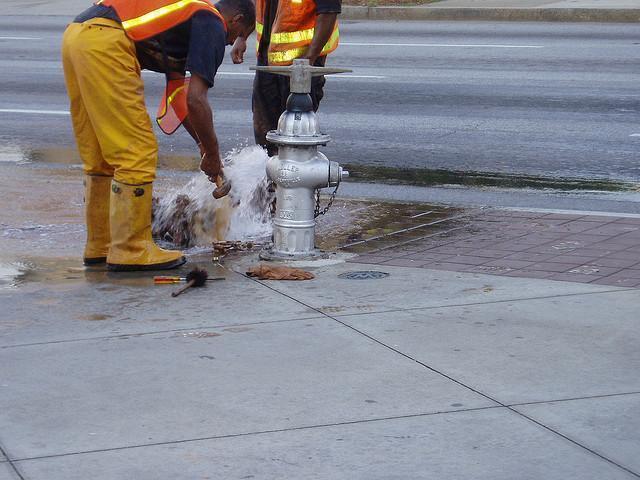Who caused the water to flood out?
Pick the correct solution from the four options below to address the question.
Options: Mayor, fireman, vandal, these men. These men. Who is paying the person with the hammer?
Make your selection and explain in format: 'Answer: answer
Rationale: rationale.'
Options: City, president, no one, criminals. Answer: city.
Rationale: This is usually the case. 